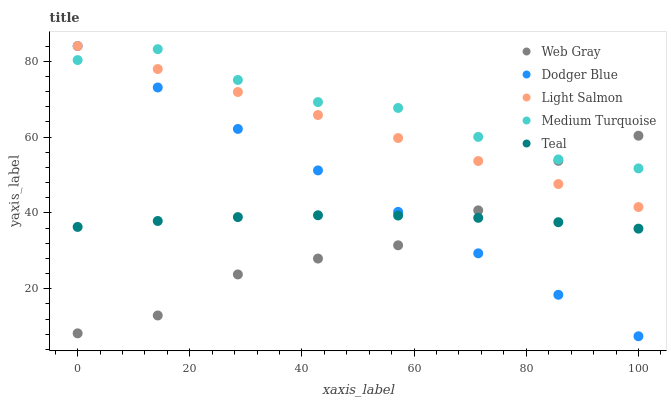Does Web Gray have the minimum area under the curve?
Answer yes or no. Yes. Does Medium Turquoise have the maximum area under the curve?
Answer yes or no. Yes. Does Dodger Blue have the minimum area under the curve?
Answer yes or no. No. Does Dodger Blue have the maximum area under the curve?
Answer yes or no. No. Is Light Salmon the smoothest?
Answer yes or no. Yes. Is Web Gray the roughest?
Answer yes or no. Yes. Is Dodger Blue the smoothest?
Answer yes or no. No. Is Dodger Blue the roughest?
Answer yes or no. No. Does Dodger Blue have the lowest value?
Answer yes or no. Yes. Does Web Gray have the lowest value?
Answer yes or no. No. Does Dodger Blue have the highest value?
Answer yes or no. Yes. Does Web Gray have the highest value?
Answer yes or no. No. Is Teal less than Medium Turquoise?
Answer yes or no. Yes. Is Light Salmon greater than Teal?
Answer yes or no. Yes. Does Web Gray intersect Teal?
Answer yes or no. Yes. Is Web Gray less than Teal?
Answer yes or no. No. Is Web Gray greater than Teal?
Answer yes or no. No. Does Teal intersect Medium Turquoise?
Answer yes or no. No. 